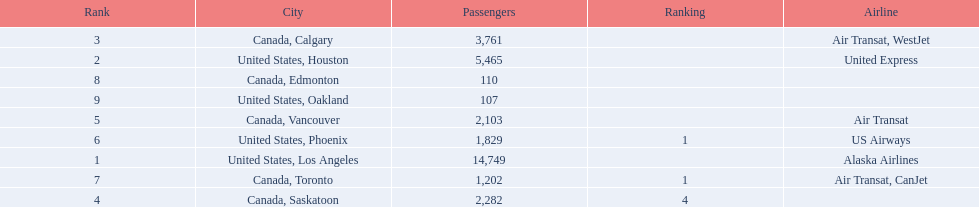Which airport has the least amount of passengers? 107. What airport has 107 passengers? United States, Oakland. 